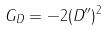<formula> <loc_0><loc_0><loc_500><loc_500>G _ { D } = - 2 ( D ^ { \prime \prime } ) ^ { 2 }</formula> 